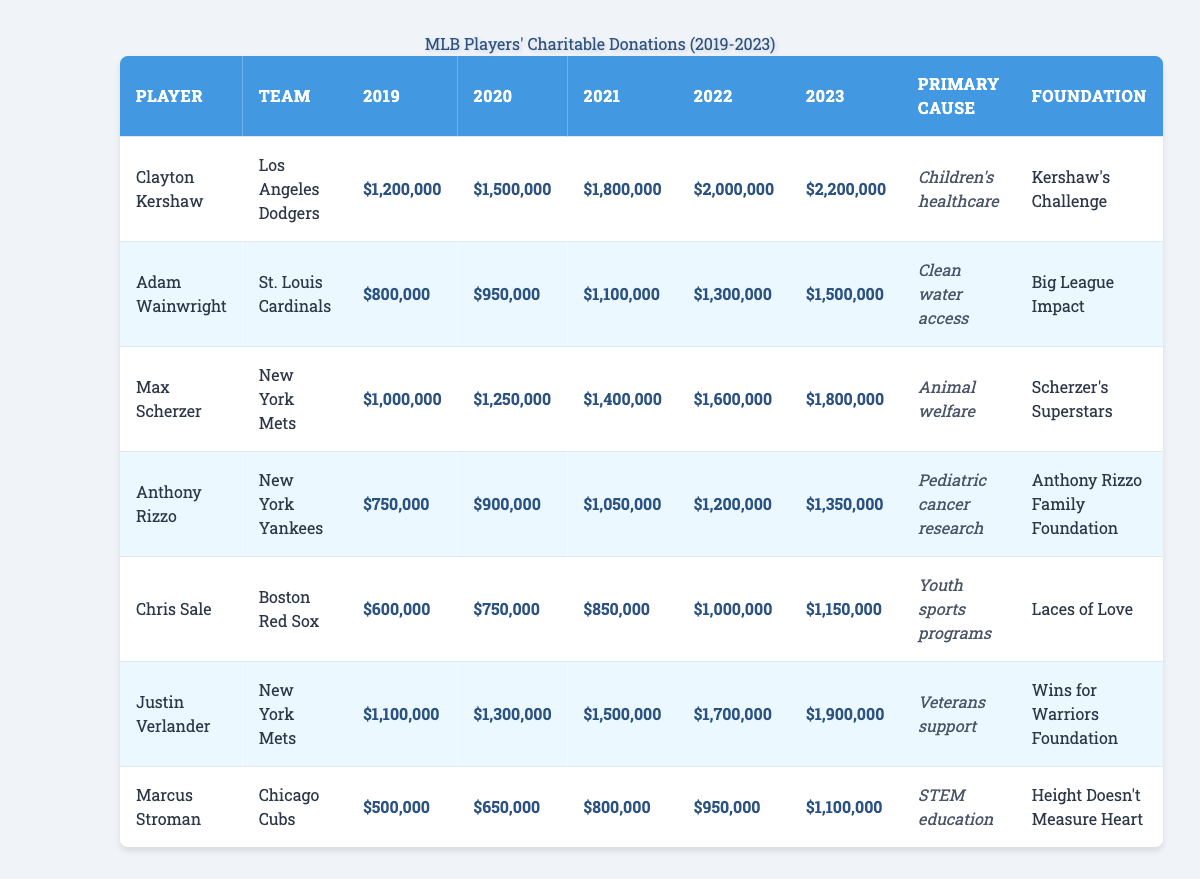What was Clayton Kershaw's total donation over the past five years? To find the total donation, sum Kershaw's donations from 2019 to 2023: 1,200,000 + 1,500,000 + 1,800,000 + 2,000,000 + 2,200,000 = 8,700,000
Answer: 8,700,000 Which player donated the least amount in 2019? Compare the 2019 donations: Kershaw (1,200,000), Wainwright (800,000), Scherzer (1,000,000), Rizzo (750,000), Sale (600,000), Verlander (1,100,000), Stroman (500,000). Stroman has the lowest donation of 500,000.
Answer: 500,000 What was the increase in donations for Justin Verlander from 2019 to 2023? Subtract Verlander's 2019 donation (1,100,000) from his 2023 donation (1,900,000): 1,900,000 - 1,100,000 = 800,000.
Answer: 800,000 Did all players have an increase in donations every year? Check each player's yearly donation values. Some players, like Chris Sale, had increases but not consistently each year. Hence, the statement is false.
Answer: No What is the average donation made by Marcus Stroman from 2019 to 2023? To calculate the average, sum Stroman's donations: 500,000 + 650,000 + 800,000 + 950,000 + 1,100,000 = 3,000,000. Divide by 5 (the number of years): 3,000,000 / 5 = 600,000.
Answer: 600,000 Which foundation received the highest total amount in donations from 2019 to 2023? First, calculate the total donations for each foundation. Kershaw's Challenge: 8,700,000, Big League Impact: 4,800,000, Scherzer's Superstars: 6,000,000, Anthony Rizzo Family Foundation: 4,800,000, Laces of Love: 3,250,000, Wins for Warriors Foundation: 7,700,000, Height Doesn't Measure Heart: 3,000,000. Kershaw's Challenge received the most at 8,700,000.
Answer: Kershaw's Challenge How much more did the New York Mets donate compared to the Boston Red Sox in 2023? Sum the donations for the Mets (Scherzer and Verlander): 1,800,000 + 1,900,000 = 3,700,000. For the Red Sox (Sale): 1,150,000. Now subtract: 3,700,000 - 1,150,000 = 2,550,000.
Answer: 2,550,000 What is the total donation for all players in 2020? Sum the 2020 donations: 1,500,000 (Kershaw) + 950,000 (Wainwright) + 1,250,000 (Scherzer) + 900,000 (Rizzo) + 750,000 (Sale) + 1,300,000 (Verlander) + 650,000 (Stroman) = 7,300,000.
Answer: 7,300,000 Which primary cause received the most significant donation in 2023? Calculate donations for 2023: Children's healthcare (2,200,000), Clean water access (1,500,000), Animal welfare (1,800,000), Pediatric cancer research (1,350,000), Youth sports programs (1,150,000), Veterans support (1,900,000), STEM education (1,100,000). The highest is for Children's healthcare (2,200,000).
Answer: Children's healthcare 